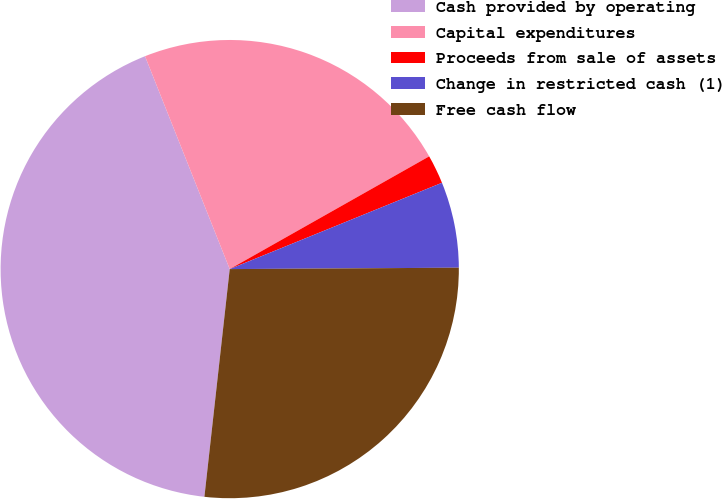Convert chart. <chart><loc_0><loc_0><loc_500><loc_500><pie_chart><fcel>Cash provided by operating<fcel>Capital expenditures<fcel>Proceeds from sale of assets<fcel>Change in restricted cash (1)<fcel>Free cash flow<nl><fcel>42.21%<fcel>22.84%<fcel>2.04%<fcel>6.05%<fcel>26.86%<nl></chart> 